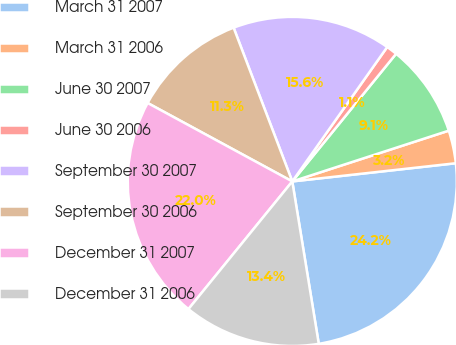<chart> <loc_0><loc_0><loc_500><loc_500><pie_chart><fcel>March 31 2007<fcel>March 31 2006<fcel>June 30 2007<fcel>June 30 2006<fcel>September 30 2007<fcel>September 30 2006<fcel>December 31 2007<fcel>December 31 2006<nl><fcel>24.19%<fcel>3.23%<fcel>9.14%<fcel>1.08%<fcel>15.59%<fcel>11.29%<fcel>22.04%<fcel>13.44%<nl></chart> 